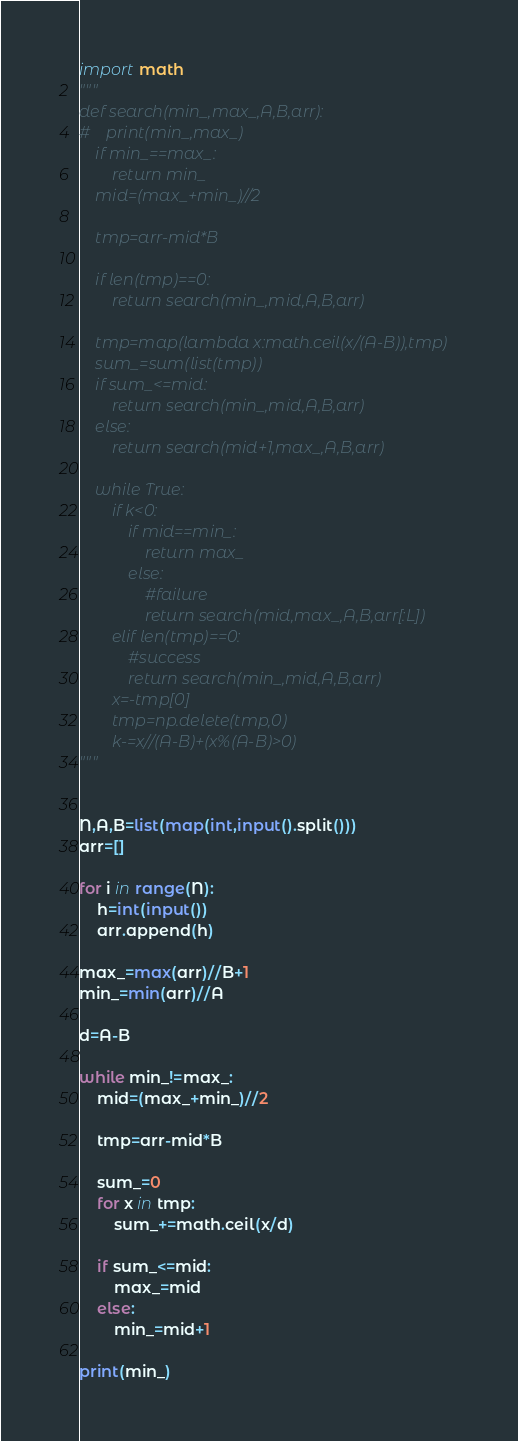<code> <loc_0><loc_0><loc_500><loc_500><_Python_>import math
"""
def search(min_,max_,A,B,arr):
#    print(min_,max_)
    if min_==max_:
        return min_
    mid=(max_+min_)//2
    
    tmp=arr-mid*B
    
    if len(tmp)==0:
        return search(min_,mid,A,B,arr)
    
    tmp=map(lambda x:math.ceil(x/(A-B)),tmp)
    sum_=sum(list(tmp))
    if sum_<=mid:
        return search(min_,mid,A,B,arr)
    else:
        return search(mid+1,max_,A,B,arr)

    while True:
        if k<0:
            if mid==min_:
                return max_
            else:
                #failure
                return search(mid,max_,A,B,arr[:L])
        elif len(tmp)==0:
            #success
            return search(min_,mid,A,B,arr)
        x=-tmp[0]
        tmp=np.delete(tmp,0)
        k-=x//(A-B)+(x%(A-B)>0)
"""
        
    
N,A,B=list(map(int,input().split()))
arr=[]

for i in range(N):
    h=int(input())
    arr.append(h)

max_=max(arr)//B+1
min_=min(arr)//A

d=A-B

while min_!=max_:
    mid=(max_+min_)//2
    
    tmp=arr-mid*B
    
    sum_=0
    for x in tmp:
        sum_+=math.ceil(x/d)
    
    if sum_<=mid:
        max_=mid
    else:
        min_=mid+1

print(min_)</code> 